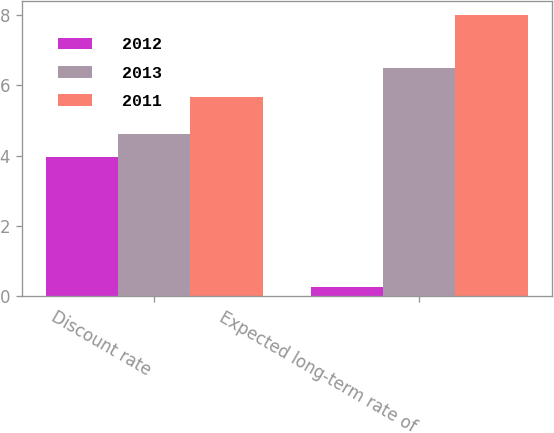<chart> <loc_0><loc_0><loc_500><loc_500><stacked_bar_chart><ecel><fcel>Discount rate<fcel>Expected long-term rate of<nl><fcel>2012<fcel>3.95<fcel>0.25<nl><fcel>2013<fcel>4.6<fcel>6.5<nl><fcel>2011<fcel>5.65<fcel>8<nl></chart> 